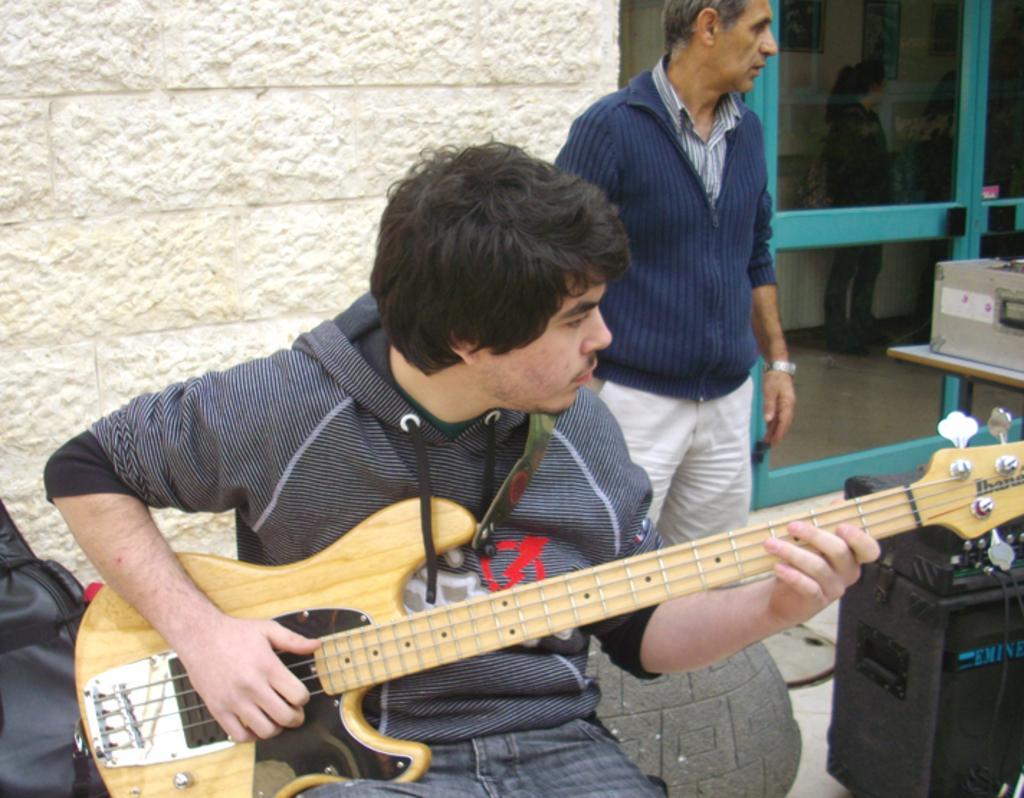Can you describe this image briefly? In this image I can see two men among them one man is sitting and playing a guitar and other man is standing. On the right side I can see there is a speaker. Behind these people we have a white color wall. 